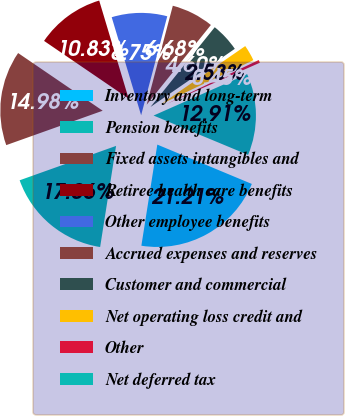Convert chart to OTSL. <chart><loc_0><loc_0><loc_500><loc_500><pie_chart><fcel>Inventory and long-term<fcel>Pension benefits<fcel>Fixed assets intangibles and<fcel>Retiree health care benefits<fcel>Other employee benefits<fcel>Accrued expenses and reserves<fcel>Customer and commercial<fcel>Net operating loss credit and<fcel>Other<fcel>Net deferred tax<nl><fcel>21.21%<fcel>17.06%<fcel>14.98%<fcel>10.83%<fcel>8.75%<fcel>6.68%<fcel>4.6%<fcel>2.53%<fcel>0.45%<fcel>12.91%<nl></chart> 